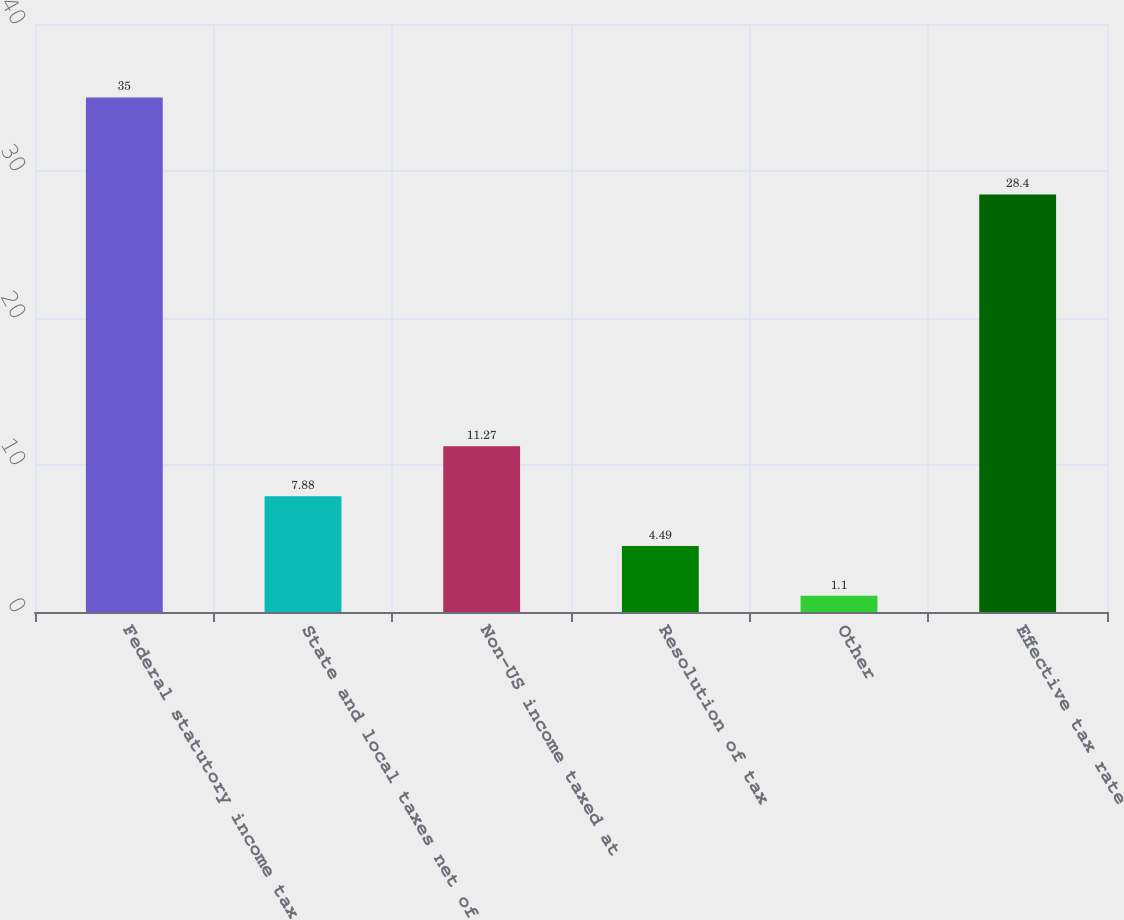<chart> <loc_0><loc_0><loc_500><loc_500><bar_chart><fcel>Federal statutory income tax<fcel>State and local taxes net of<fcel>Non-US income taxed at<fcel>Resolution of tax<fcel>Other<fcel>Effective tax rate<nl><fcel>35<fcel>7.88<fcel>11.27<fcel>4.49<fcel>1.1<fcel>28.4<nl></chart> 